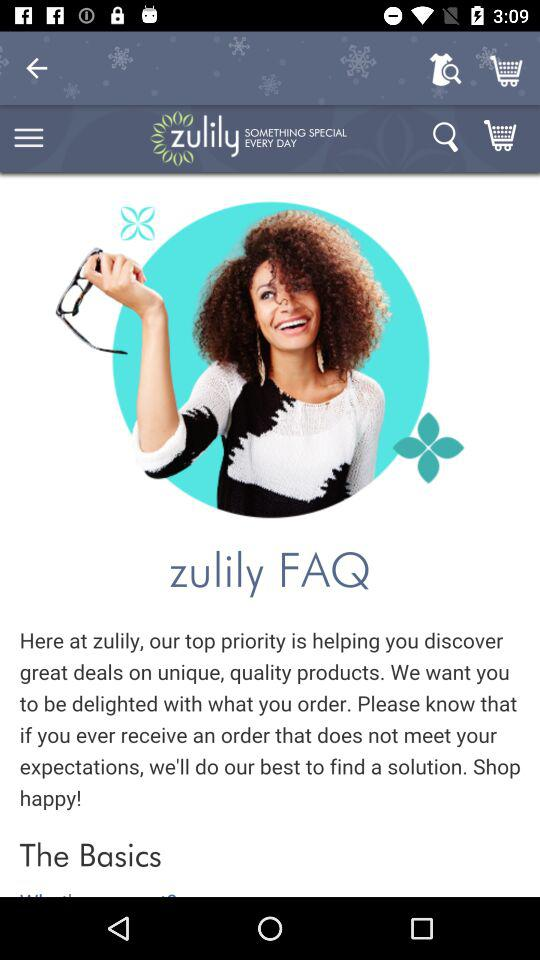How many items are in the cart?
When the provided information is insufficient, respond with <no answer>. <no answer> 